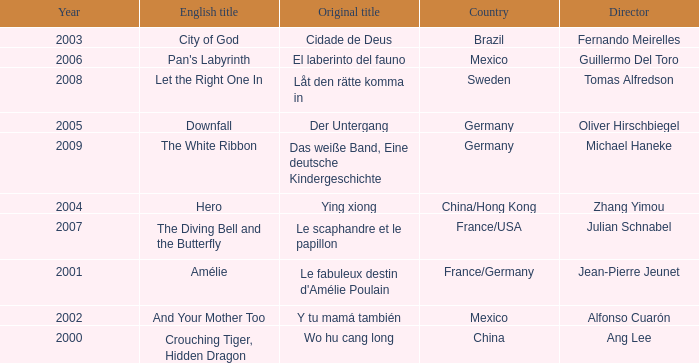Tell me the country for julian schnabel France/USA. 